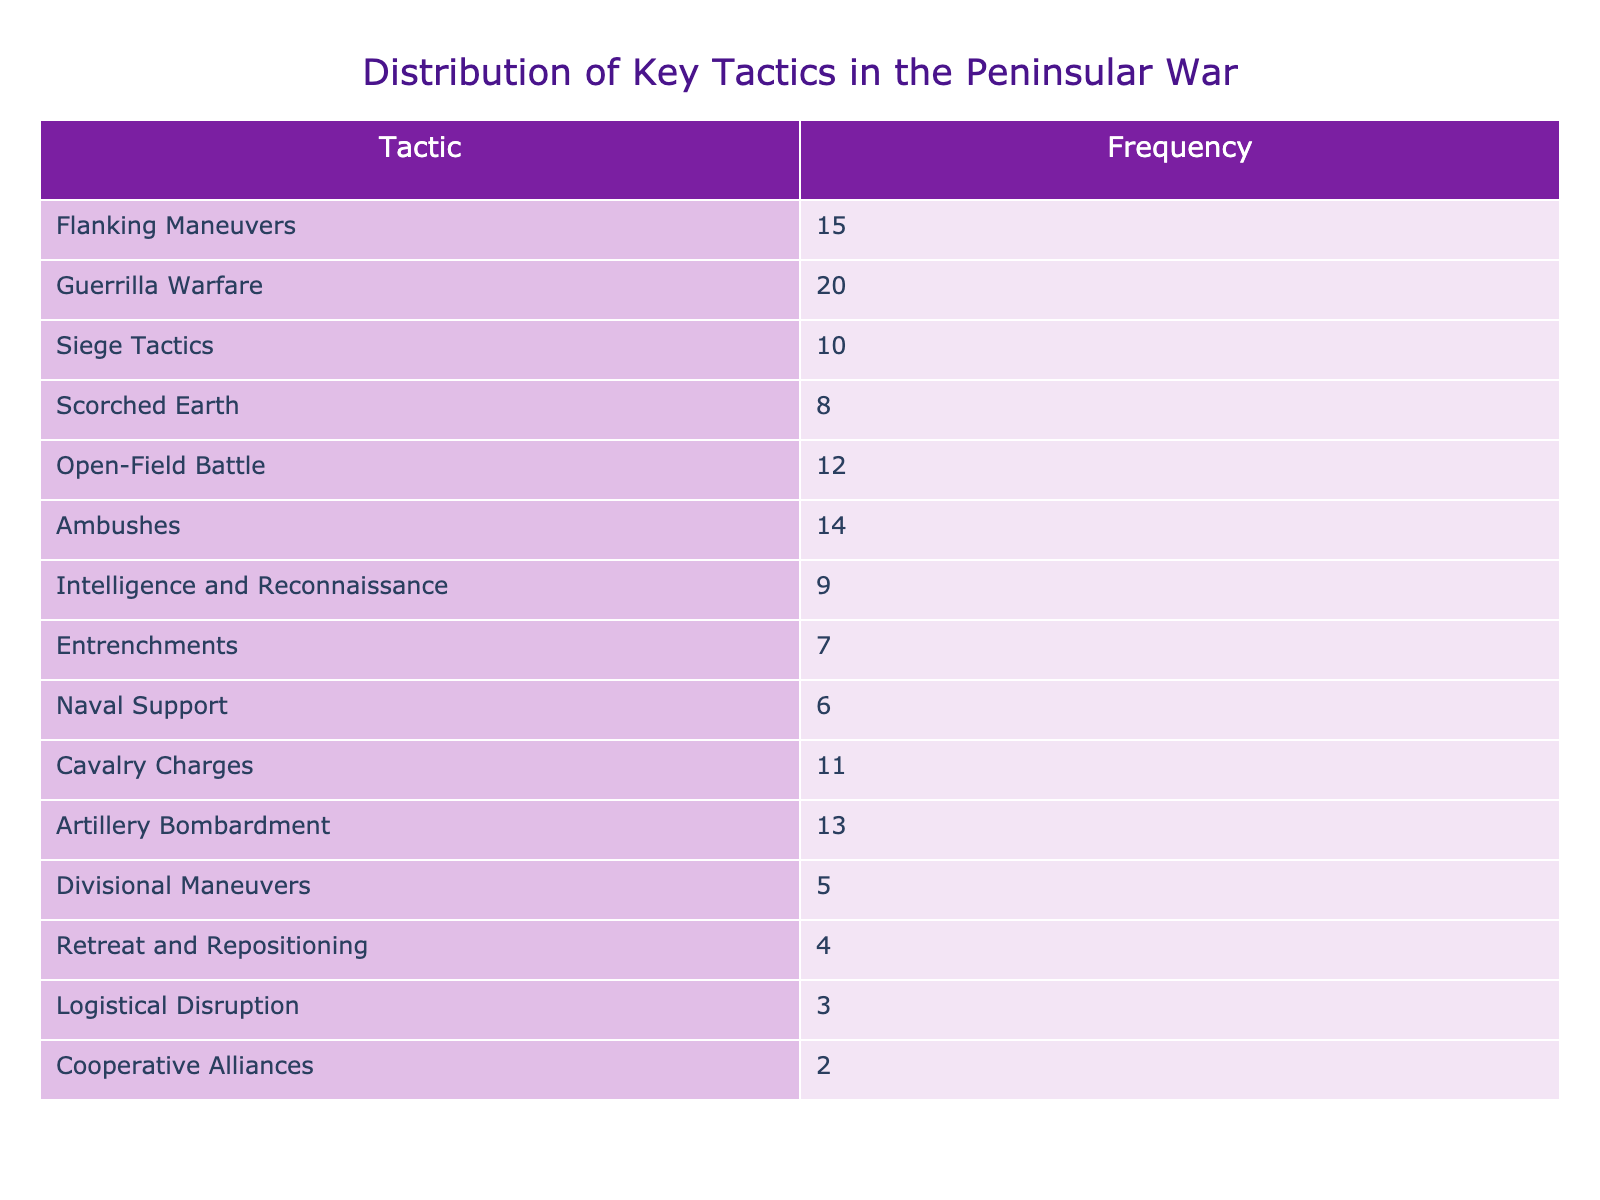What is the frequency of Guerrilla Warfare tactics? Looking at the table, the frequency of Guerrilla Warfare is explicitly listed next to it as 20.
Answer: 20 Which tactic was used the least frequently? By examining the table, we see the lowest frequency listed is for Cooperative Alliances, which has a frequency of 2.
Answer: Cooperative Alliances What is the total frequency of tactics involving cavalry (Cavalry Charges, Flanking Maneuvers, and Ambushes)? The frequencies for Cavalry Charges, Flanking Maneuvers, and Ambushes are listed as 11, 15, and 14 respectively. Adding these together: 11 + 15 + 14 = 40 gives a total frequency of 40.
Answer: 40 Which tactic has a frequency greater than 10 but less than 15? The table specifies the frequencies of several tactics: Flanking Maneuvers (15), Open-Field Battle (12), Ambushes (14). The only tactics with a frequency greater than 10 but less than 15 are Open-Field Battle (12) and Ambushes (14).
Answer: Open-Field Battle and Ambushes Is the frequency of Naval Support greater than that of Scorched Earth? The frequency for Naval Support is 6, and for Scorched Earth, it is 8. Comparatively, 6 is not greater than 8. Therefore, the statement is false.
Answer: No What is the average frequency of all tactics listed in the table? To find the average, we first sum all the frequencies: 15 + 20 + 10 + 8 + 12 + 14 + 9 + 7 + 6 + 11 + 13 + 5 + 4 + 3 + 2 = 132. There are a total of 15 tactics, so the average frequency is 132 divided by 15, which equals 8.8.
Answer: 8.8 How many more instances of Guerrilla Warfare were used compared to Siege Tactics? The frequency of Guerrilla Warfare is 20 and the frequency of Siege Tactics is 10. The difference is calculated by subtracting: 20 - 10 = 10.
Answer: 10 What percentage of the total frequency does the Scorched Earth tactic represent? The total frequency is 132. The frequency of Scorched Earth is 8. The percentage is calculated by (8 / 132) * 100, which equals approximately 6.06%.
Answer: 6.06% 